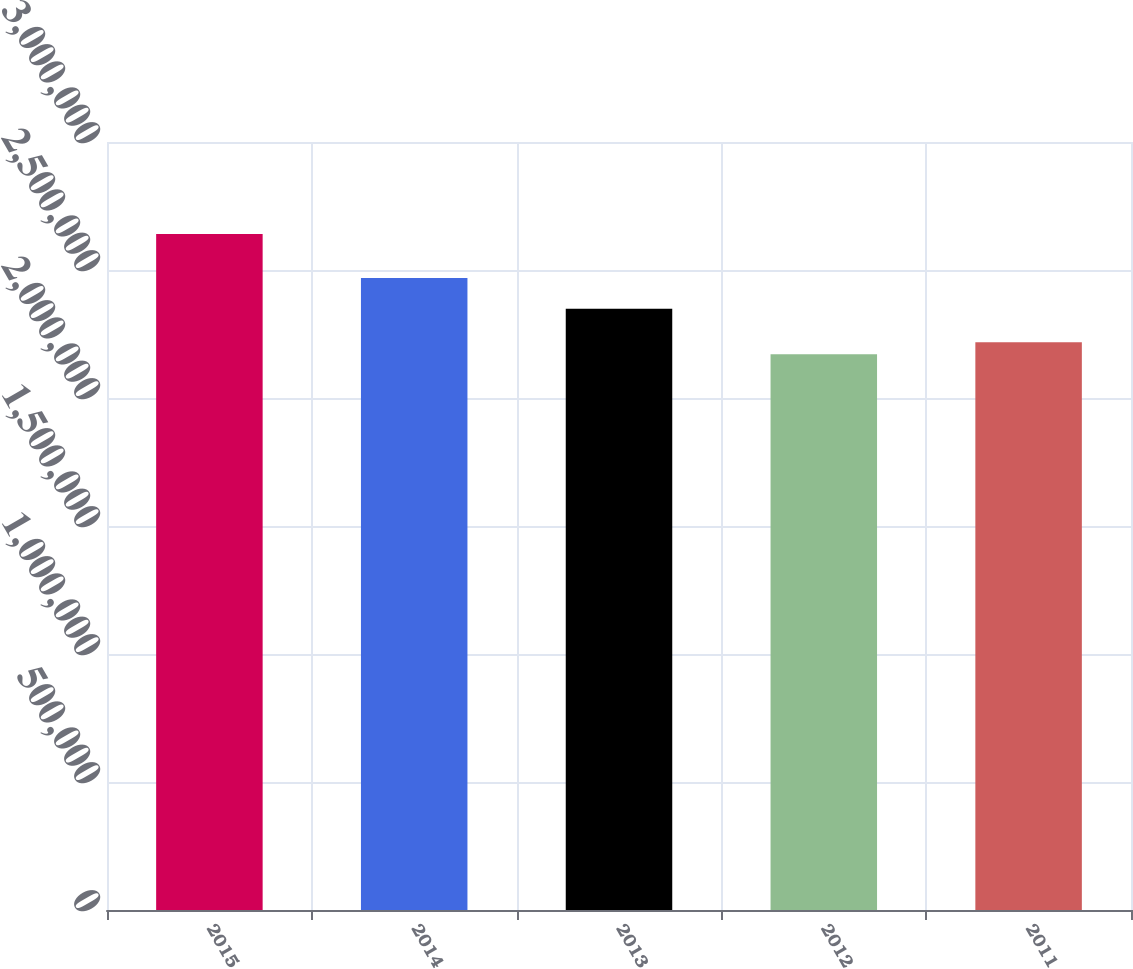<chart> <loc_0><loc_0><loc_500><loc_500><bar_chart><fcel>2015<fcel>2014<fcel>2013<fcel>2012<fcel>2011<nl><fcel>2.641e+06<fcel>2.469e+06<fcel>2.349e+06<fcel>2.171e+06<fcel>2.218e+06<nl></chart> 